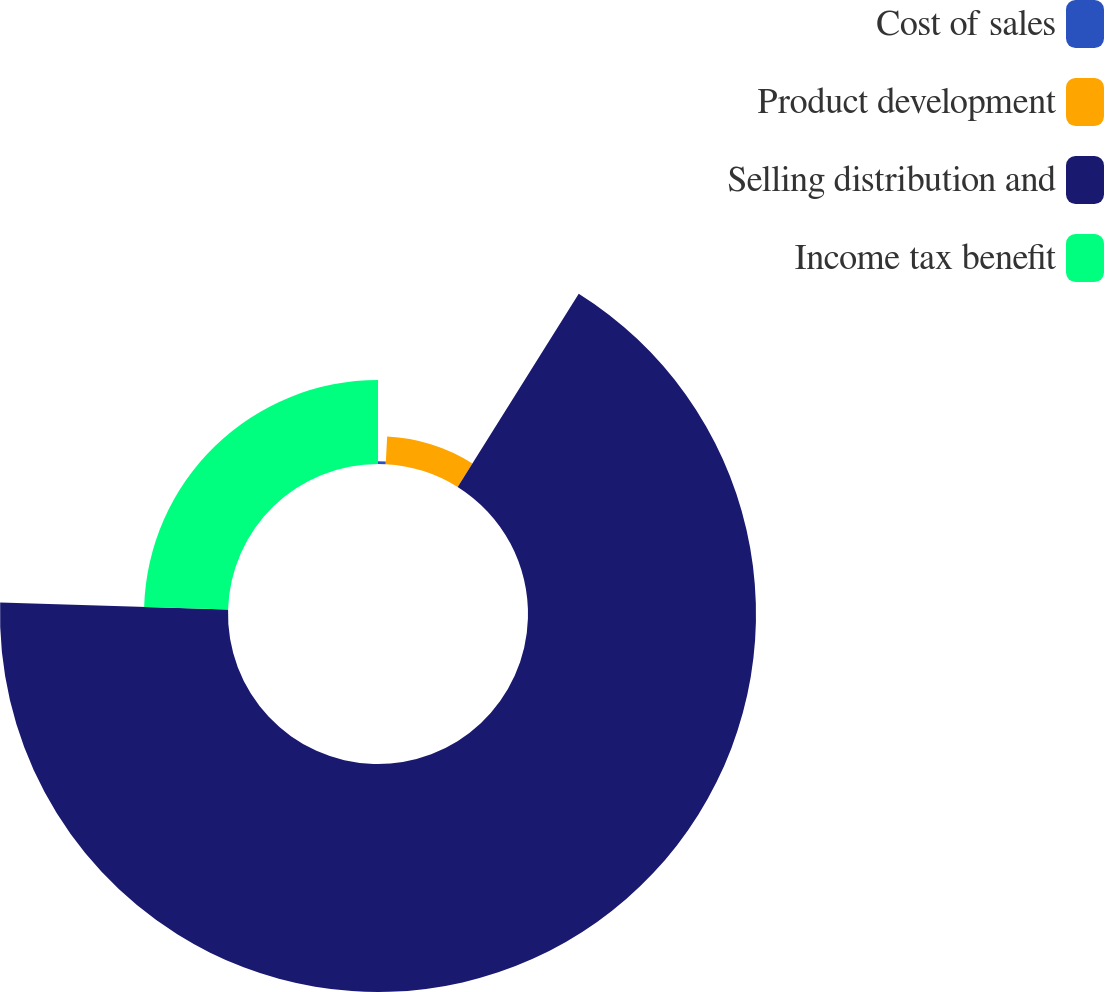Convert chart. <chart><loc_0><loc_0><loc_500><loc_500><pie_chart><fcel>Cost of sales<fcel>Product development<fcel>Selling distribution and<fcel>Income tax benefit<nl><fcel>0.82%<fcel>8.09%<fcel>66.57%<fcel>24.52%<nl></chart> 